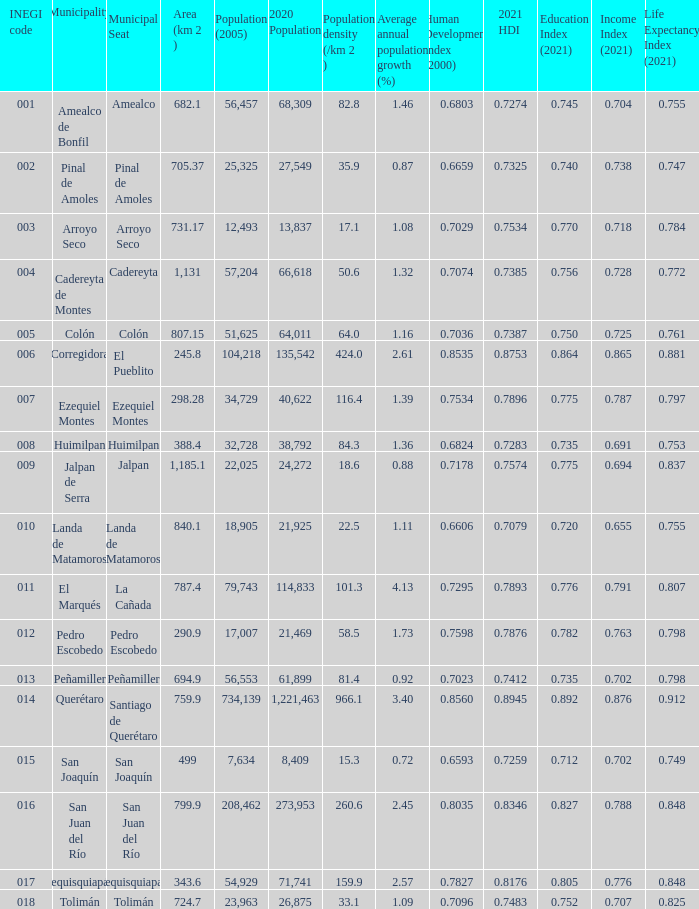WHich INEGI code has a Population density (/km 2 ) smaller than 81.4 and 0.6593 Human Development Index (2000)? 15.0. 